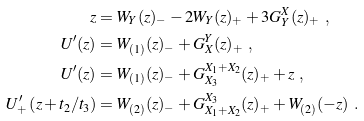Convert formula to latex. <formula><loc_0><loc_0><loc_500><loc_500>z & = W _ { Y } ( z ) _ { - } - 2 W _ { Y } ( z ) _ { + } + 3 G _ { Y } ^ { X } ( z ) _ { + } \ , \\ U ^ { \prime } ( z ) & = W _ { ( 1 ) } ( z ) _ { - } + G _ { X } ^ { Y } ( z ) _ { + } \ , \\ U ^ { \prime } ( z ) & = W _ { ( 1 ) } ( z ) _ { - } + G _ { X _ { 3 } } ^ { X _ { 1 } + X _ { 2 } } ( z ) _ { + } + z \ , \\ U ^ { \prime } _ { + } \left ( z + t _ { 2 } / t _ { 3 } \right ) & = W _ { ( 2 ) } ( z ) _ { - } + G _ { X _ { 1 } + X _ { 2 } } ^ { X _ { 3 } } ( z ) _ { + } + W _ { ( 2 ) } ( - z ) \ .</formula> 